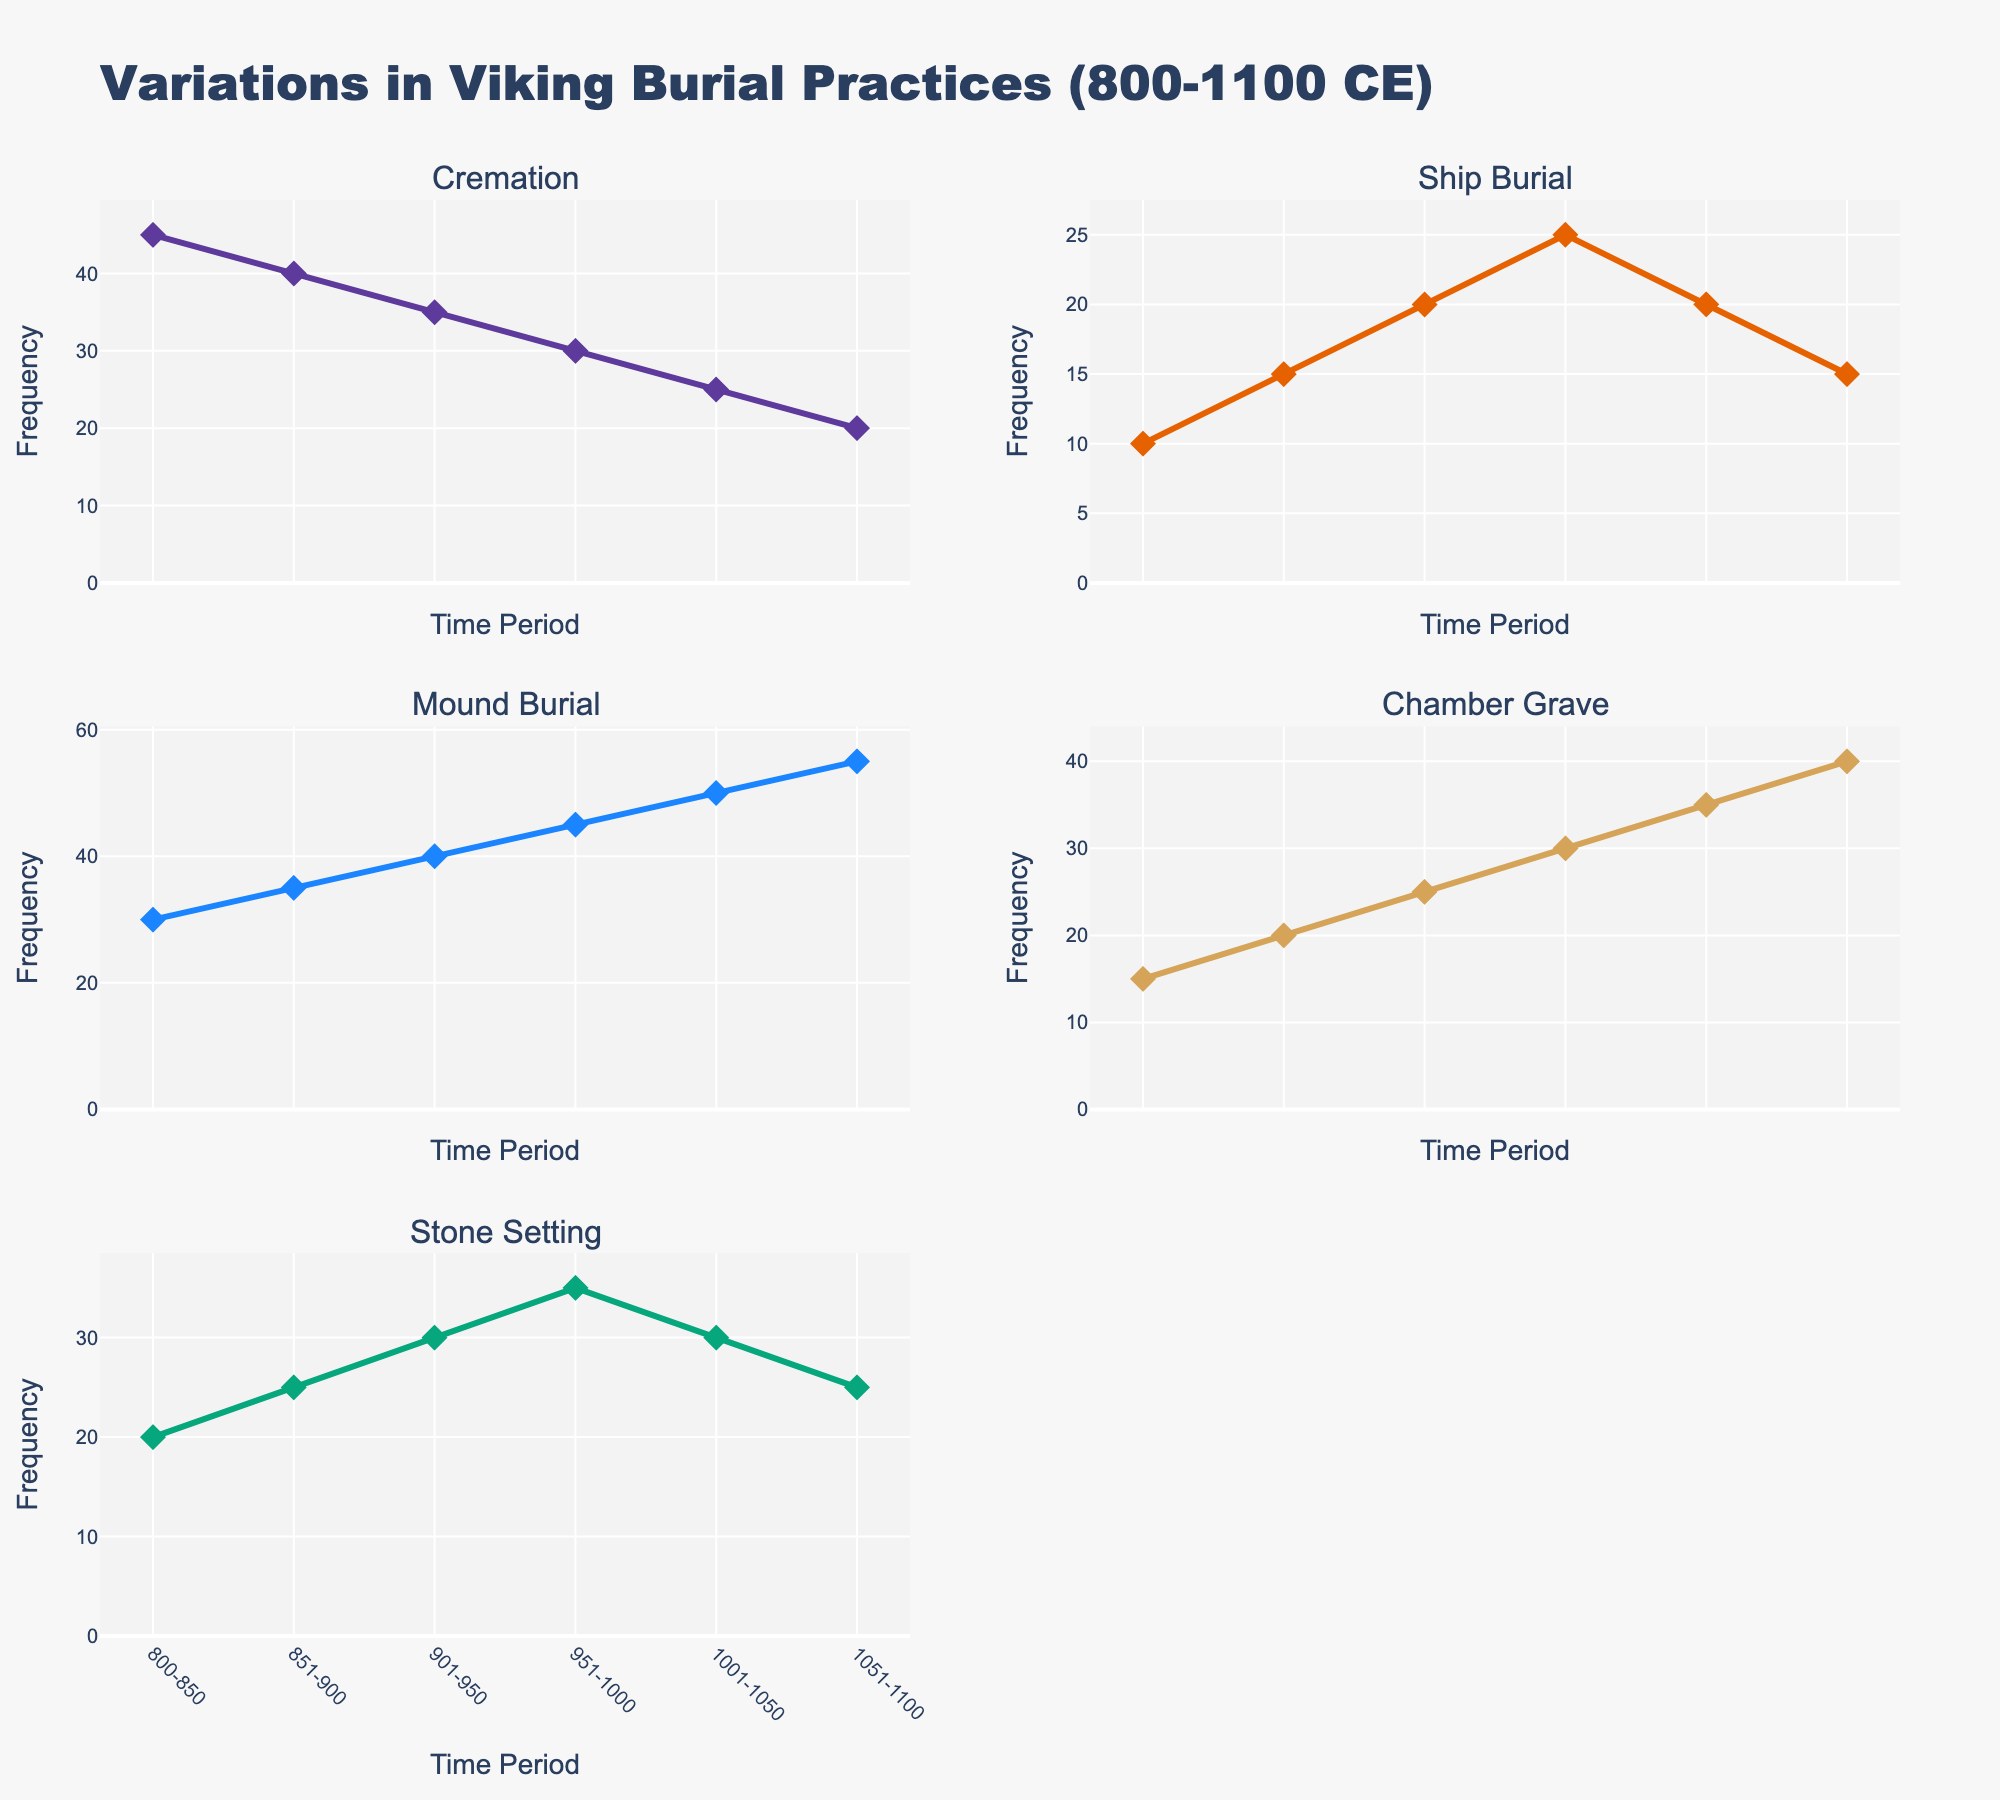What's the title of the figure? The title is displayed at the top of the figure, which is "Variations in Viking Burial Practices (800-1100 CE)."
Answer: Variations in Viking Burial Practices (800-1100 CE) How many total data points are plotted across all subplots? Each burial practice is assessed over six time periods, resulting in 5 types of burial practices, each assessed in 6 time periods. Since each subplot has the same number of data points, we calculate the total as 5 * 6 = 30.
Answer: 30 In which time period does the Mound Burial practice have the highest frequency? By looking at the subplot for Mound Burial, we see that the frequency increases with each time period and reaches its peak in the period 1051-1100.
Answer: 1051-1100 What is the frequency difference of Ship Burial between the periods 800-850 and 951-1000? From the subplot for Ship Burial, we can see that the frequency in 800-850 is 10 and in 951-1000 is 25. The difference is calculated as 25 - 10 = 15.
Answer: 15 Which burial practice had the most significant increase in frequency from 800-850 to 951-1000? By examining each subplot and comparing the differences between these time periods, we see that Mound Burial had the most significant increase, starting at 30 in 800-850 and reaching 45 in 951-1000. This is an increase of 15.
Answer: Mound Burial How does the frequency trend for Cremation change over time? The Cremation subplot shows a decreasing trend, starting at 45 and continuing to decrease every time period until it reaches 20 by the period 1051-1100.
Answer: Decreases Which burial practices had a decline in frequency between 951-1000 and 1001-1050? By examining the subplots, Ship Burial and Stone Setting decreased in frequency between these time periods.
Answer: Ship Burial, Stone Setting Between which time periods does the Stone Setting burial practice first exceed the 25 frequency mark? Looking at the subplot for Stone Setting, it first exceeds 25 in the period 901-950, moving from 20 in the previous period to 30.
Answer: 901-950 What can be said about the overall trends of Chamber Grave practices? By observing the subplot for Chamber Grave, it shows a steady increase, starting at 15 in 800-850 and reaching 40 in 1051-1100, indicating a generally rising trend.
Answer: Rising trend 